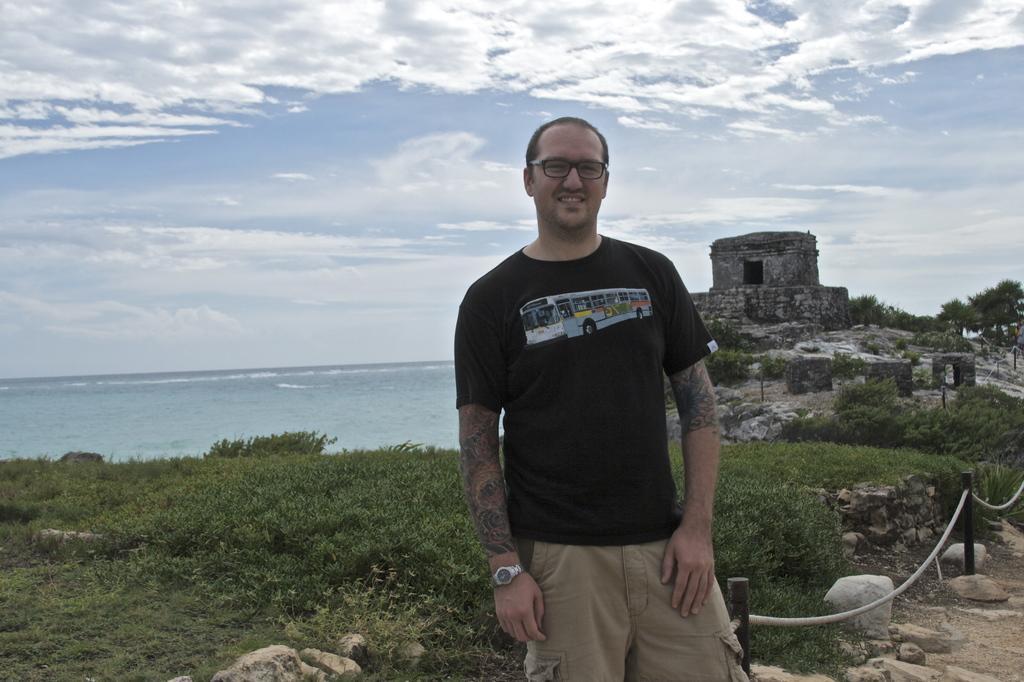Could you give a brief overview of what you see in this image? In this image I can see in the middle a man is standing, he wore a black color t-shirt and short. Behind him there are plants and there is water at the back side, on the right side there is an old construction. At the top it is the sky. 